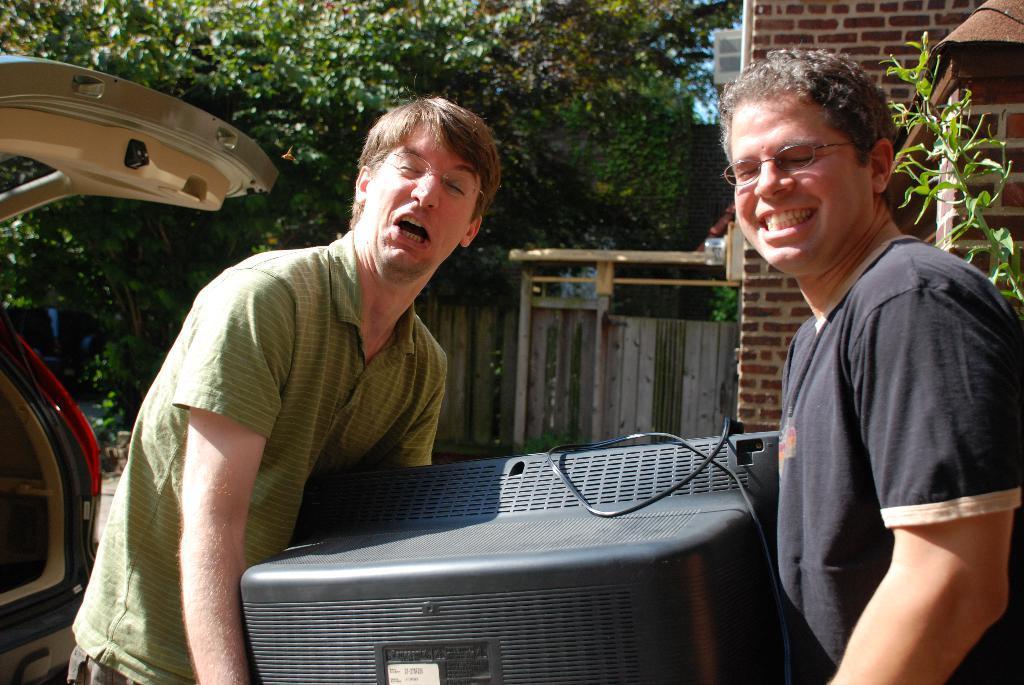Please provide a concise description of this image. In the image I can see two people who are holding the television and beside there is car and also I can see some trees and a brick wall. 